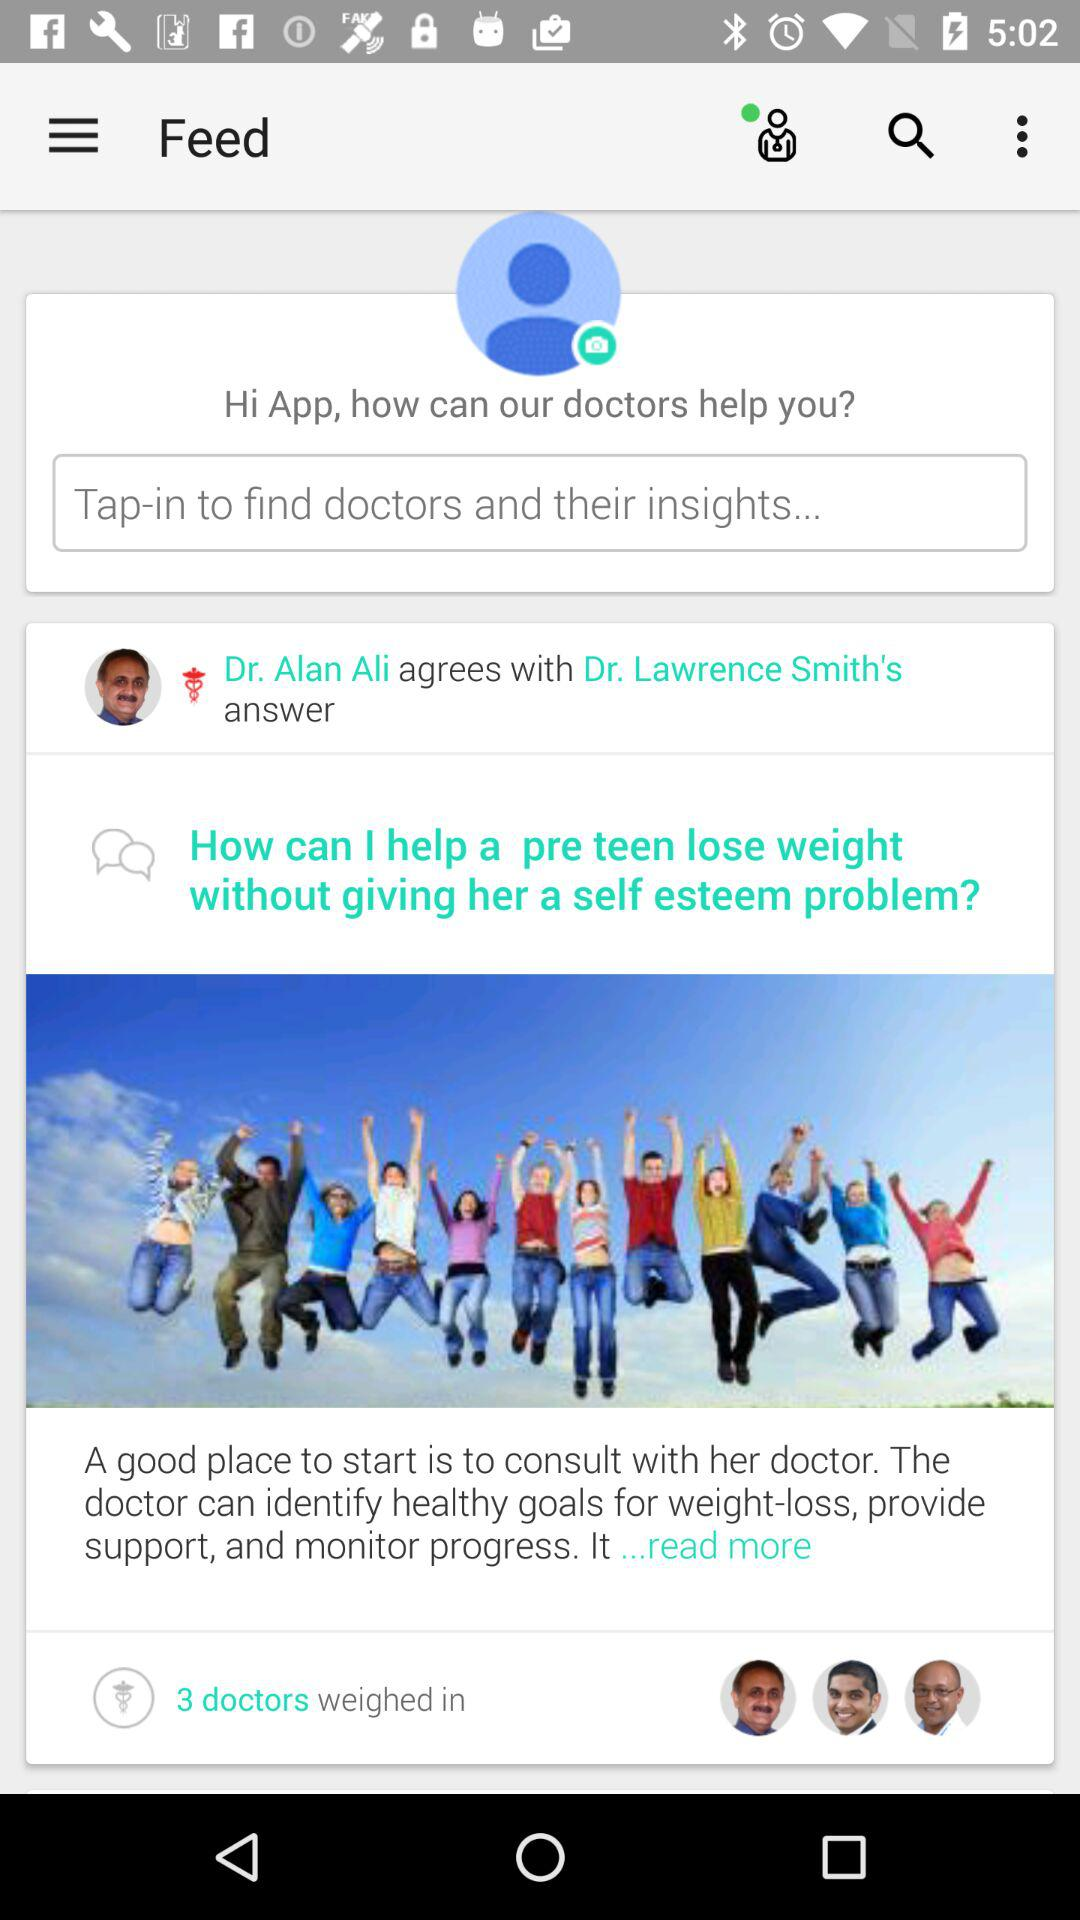How many doctors have provided an answer to the question?
Answer the question using a single word or phrase. 3 